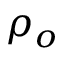Convert formula to latex. <formula><loc_0><loc_0><loc_500><loc_500>\rho _ { o }</formula> 